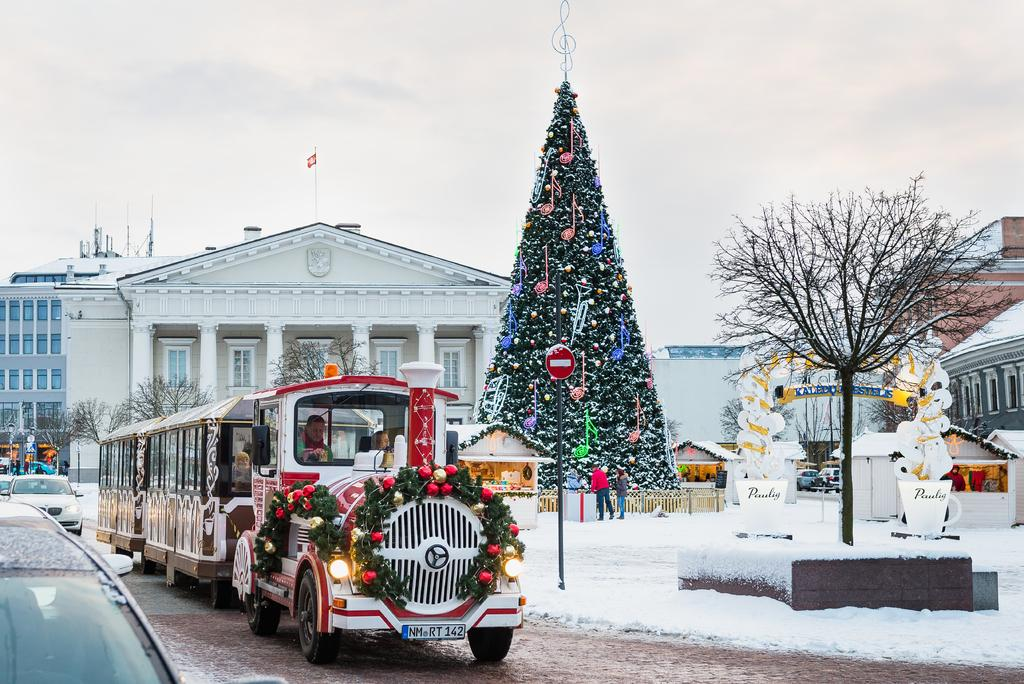What is the main subject of the image? The main subject of the image is a vehicle. Who or what is inside the vehicle? There are people sitting in the vehicle. What can be observed about the environment in the image? The image depicts a snowy environment. What type of natural element is present in the image? There is a tree in the image. What man-made object can be seen in the image? There is a pole in the image. What type of structure is visible in the image? There is a building in the image. What feature of the building is mentioned? The building has windows. What symbol is present in the image? There is a flag of a country in the image. What part of the natural environment is visible in the image? The sky is visible in the image. What type of apple is being eaten by the boy in the image? There is no boy or apple present in the image. What instrument is the drummer playing in the image? There is no drum or drummer present in the image. 